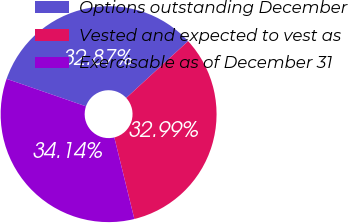Convert chart to OTSL. <chart><loc_0><loc_0><loc_500><loc_500><pie_chart><fcel>Options outstanding December<fcel>Vested and expected to vest as<fcel>Exercisable as of December 31<nl><fcel>32.87%<fcel>32.99%<fcel>34.14%<nl></chart> 